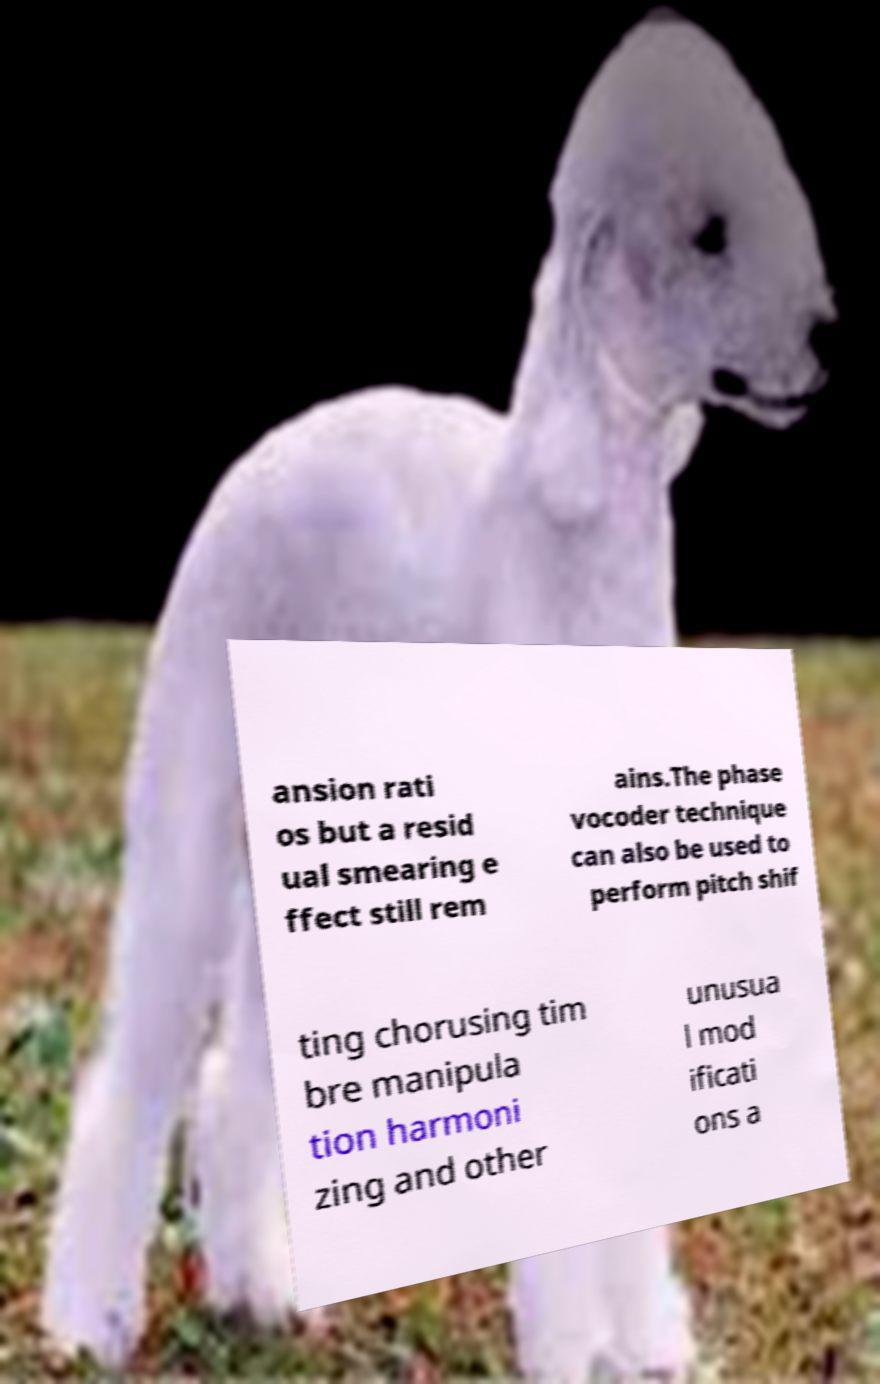Can you accurately transcribe the text from the provided image for me? ansion rati os but a resid ual smearing e ffect still rem ains.The phase vocoder technique can also be used to perform pitch shif ting chorusing tim bre manipula tion harmoni zing and other unusua l mod ificati ons a 